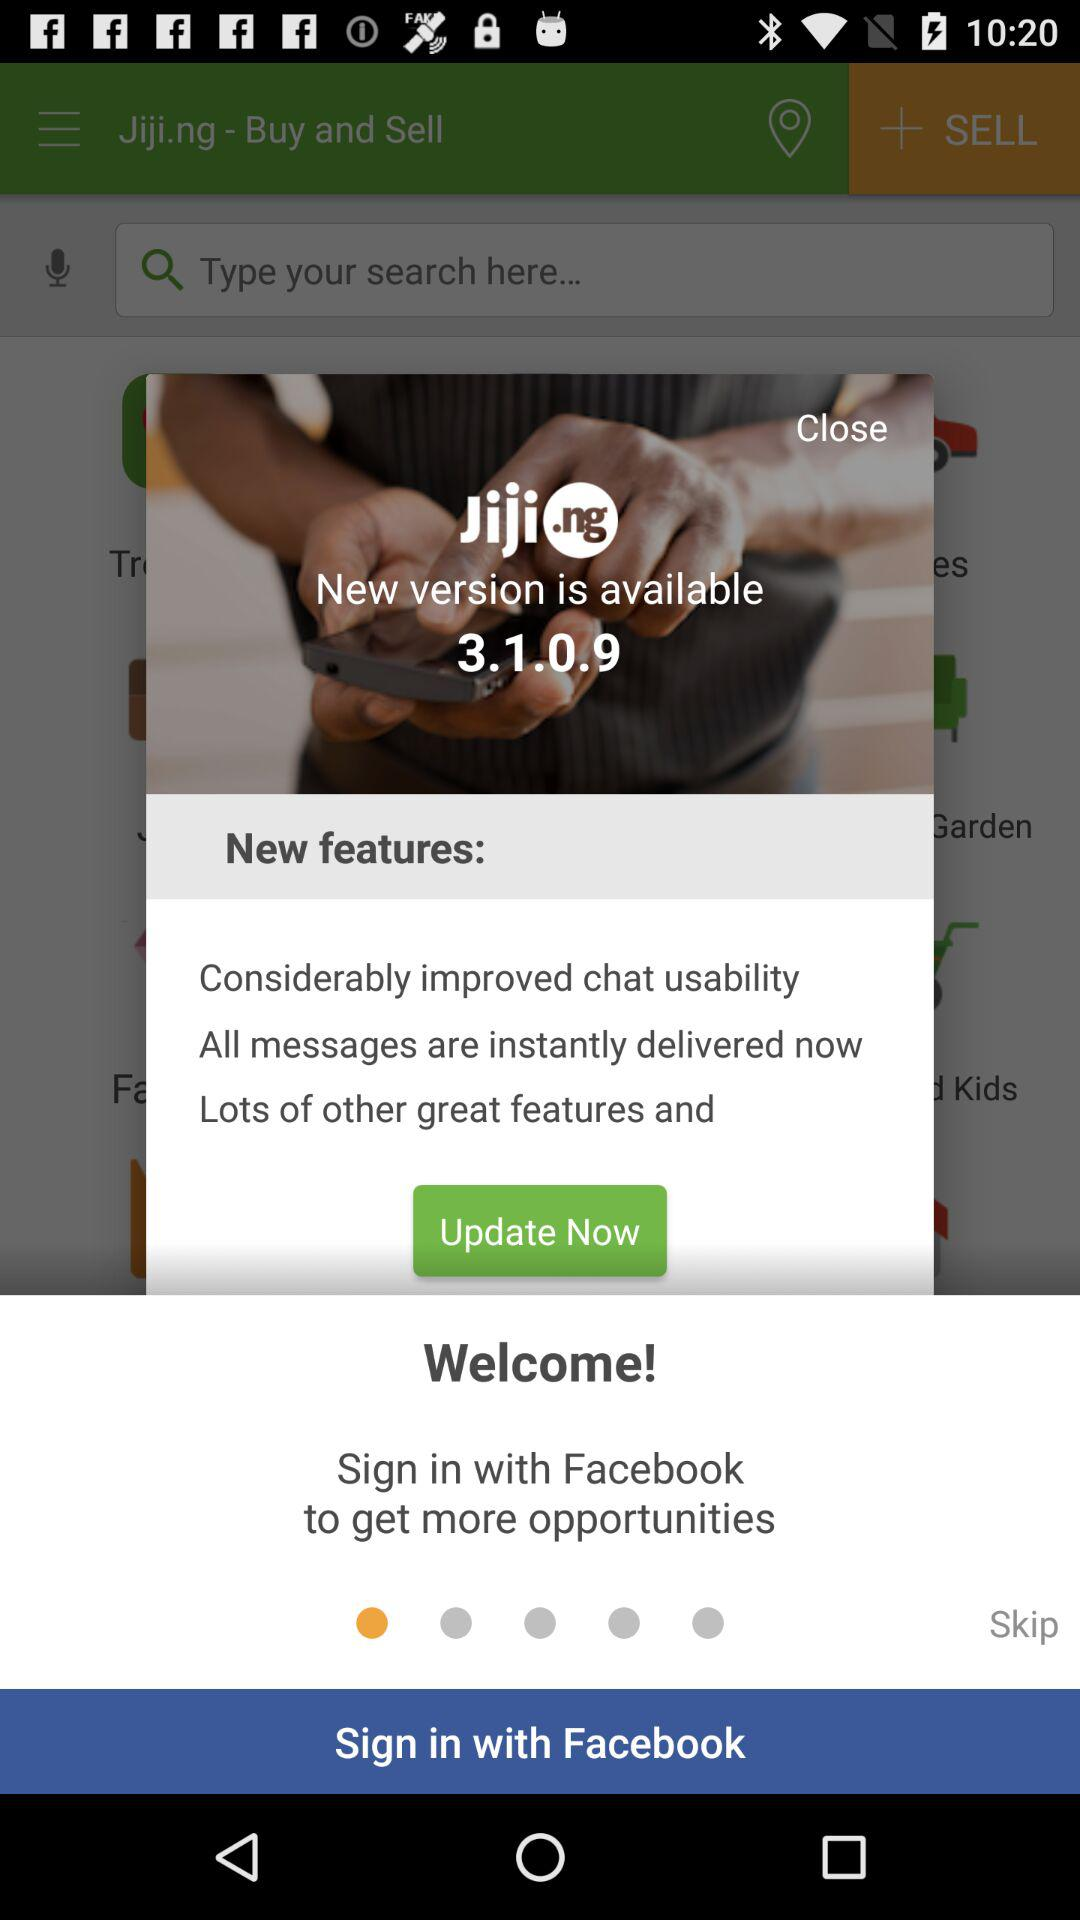What application can be used to sign in? The application that can be used to sign in is "Facebook". 